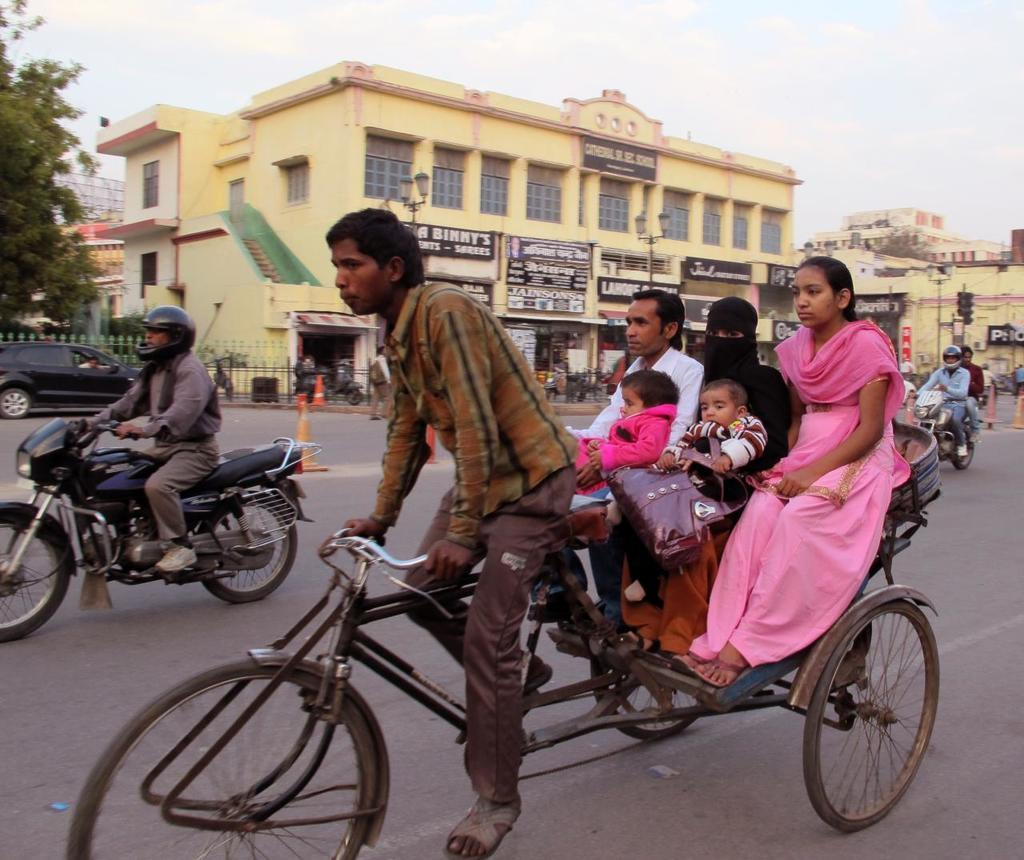What are the two types of vehicles being ridden in the image? There is a man riding a tricycle and a man riding a motorcycle in the image. What can be seen in the background of the image? There is a building visible in the image. What type of plant is present in the image? There is a tree in the image. What type of soup is being served at the restaurant in the image? There is no restaurant or soup present in the image. Can you see the heart rate monitor on the man riding the tricycle in the image? There is no heart rate monitor visible in the image. 